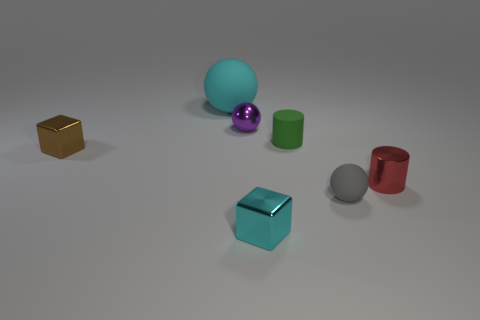Subtract all brown balls. Subtract all cyan cylinders. How many balls are left? 3 Add 1 large red balls. How many objects exist? 8 Subtract all cubes. How many objects are left? 5 Add 6 red cylinders. How many red cylinders are left? 7 Add 7 tiny gray matte things. How many tiny gray matte things exist? 8 Subtract 0 brown cylinders. How many objects are left? 7 Subtract all cyan objects. Subtract all small spheres. How many objects are left? 3 